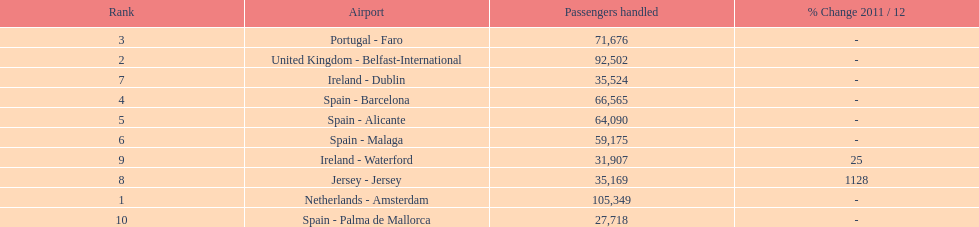Which airport had more passengers handled than the united kingdom? Netherlands - Amsterdam. Parse the table in full. {'header': ['Rank', 'Airport', 'Passengers handled', '% Change 2011 / 12'], 'rows': [['3', 'Portugal - Faro', '71,676', '-'], ['2', 'United Kingdom - Belfast-International', '92,502', '-'], ['7', 'Ireland - Dublin', '35,524', '-'], ['4', 'Spain - Barcelona', '66,565', '-'], ['5', 'Spain - Alicante', '64,090', '-'], ['6', 'Spain - Malaga', '59,175', '-'], ['9', 'Ireland - Waterford', '31,907', '25'], ['8', 'Jersey - Jersey', '35,169', '1128'], ['1', 'Netherlands - Amsterdam', '105,349', '-'], ['10', 'Spain - Palma de Mallorca', '27,718', '-']]} 